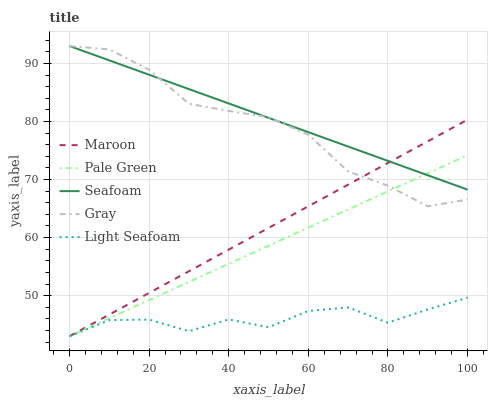Does Light Seafoam have the minimum area under the curve?
Answer yes or no. Yes. Does Seafoam have the maximum area under the curve?
Answer yes or no. Yes. Does Gray have the minimum area under the curve?
Answer yes or no. No. Does Gray have the maximum area under the curve?
Answer yes or no. No. Is Pale Green the smoothest?
Answer yes or no. Yes. Is Light Seafoam the roughest?
Answer yes or no. Yes. Is Gray the smoothest?
Answer yes or no. No. Is Gray the roughest?
Answer yes or no. No. Does Light Seafoam have the lowest value?
Answer yes or no. Yes. Does Gray have the lowest value?
Answer yes or no. No. Does Seafoam have the highest value?
Answer yes or no. Yes. Does Pale Green have the highest value?
Answer yes or no. No. Is Light Seafoam less than Seafoam?
Answer yes or no. Yes. Is Gray greater than Light Seafoam?
Answer yes or no. Yes. Does Gray intersect Pale Green?
Answer yes or no. Yes. Is Gray less than Pale Green?
Answer yes or no. No. Is Gray greater than Pale Green?
Answer yes or no. No. Does Light Seafoam intersect Seafoam?
Answer yes or no. No. 